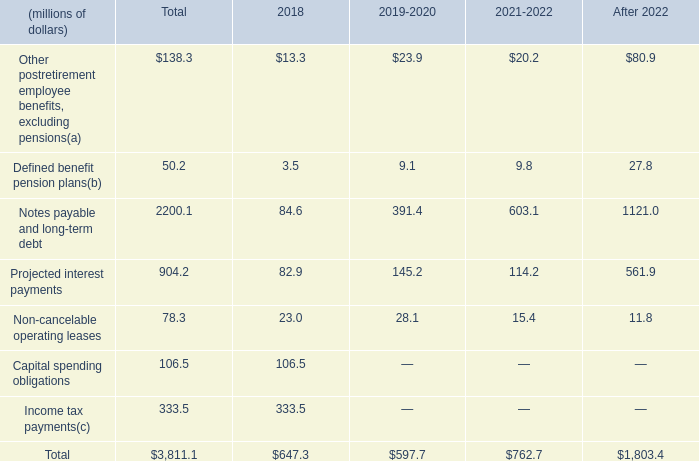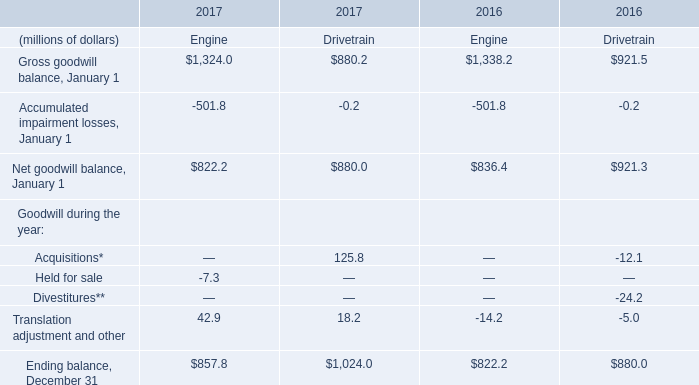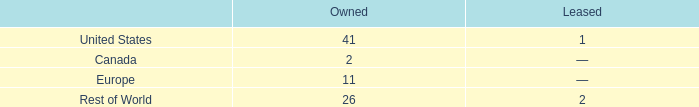When is Net goodwill balance, January 1 the largest? 
Answer: 2016. 